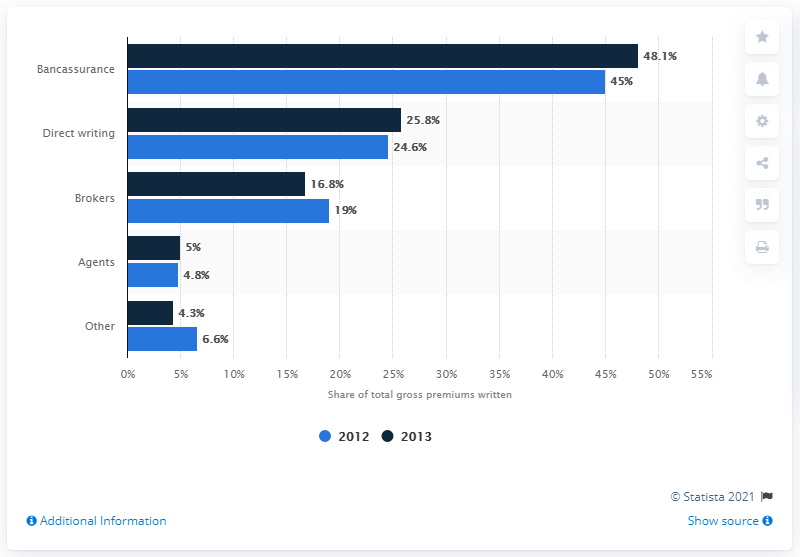List a handful of essential elements in this visual. In 2013, the market share of bancassurance in the life insurance class was 48.1%. 